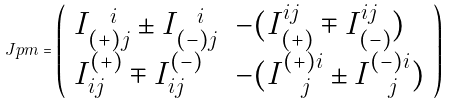<formula> <loc_0><loc_0><loc_500><loc_500>\ J p m = \left ( \begin{array} { l l } I ^ { \ \ i } _ { ( + ) j } \pm I ^ { \ \ i } _ { ( - ) j } & - ( I _ { ( + ) } ^ { i j } \mp I _ { ( - ) } ^ { i j } ) \\ I _ { i j } ^ { ( + ) } \mp I _ { i j } ^ { ( - ) } & - ( I ^ { ( + ) i } _ { \ \ j } \pm I ^ { ( - ) i } _ { \ \ j } ) \end{array} \right ) \</formula> 